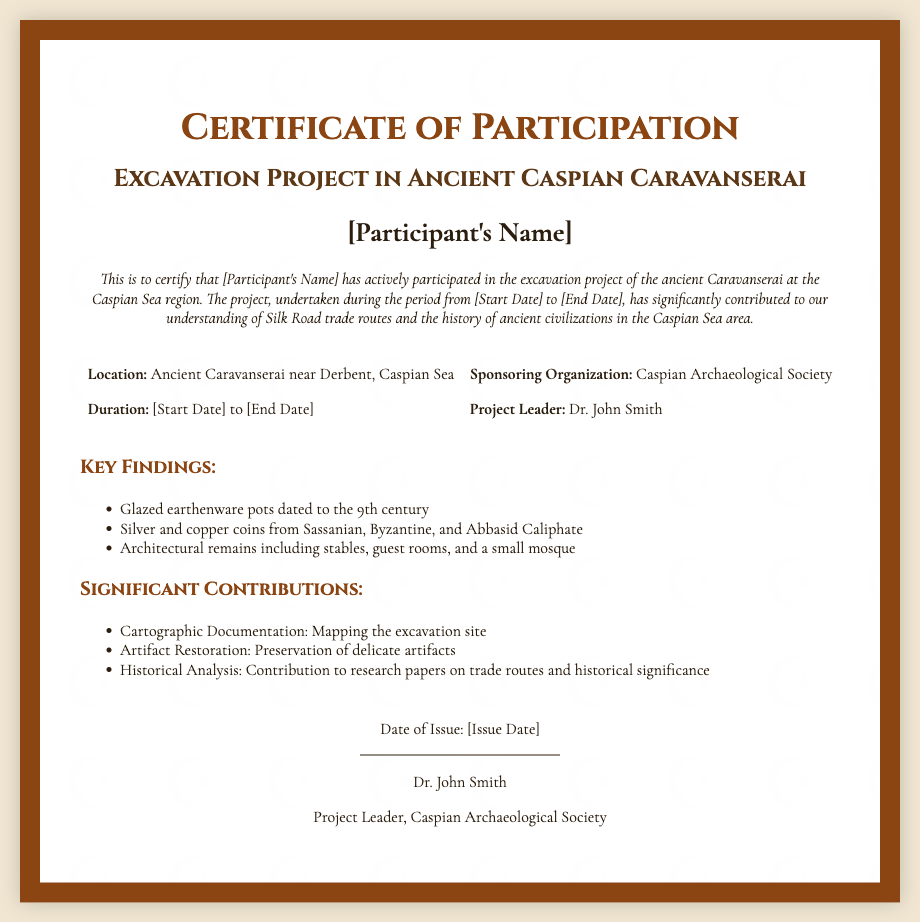What is the title of the project? The title of the project as stated in the certificate is "Excavation Project in Ancient Caspian Caravanserai".
Answer: Excavation Project in Ancient Caspian Caravanserai Who is the project leader? The document specifies the project leader's name as stated below the signature line.
Answer: Dr. John Smith What organization sponsored the project? The sponsoring organization is mentioned in the project details section.
Answer: Caspian Archaeological Society What is the location of the excavation? The document provides the location in the project details section.
Answer: Ancient Caravanserai near Derbent, Caspian Sea What are the dates of the project? The certificate includes a duration section where the start and end dates should be placed.
Answer: [Start Date] to [End Date] Name one key finding from the excavation. The document lists key findings that were discovered during the excavation.
Answer: Glazed earthenware pots dated to the 9th century What kind of artifact restoration was done? The contributions section mentions a specific type of work related to artifacts.
Answer: Preservation of delicate artifacts Who is being certified in this document? The certificate mentions the participant's name at the start of the description.
Answer: [Participant's Name] When was the certificate issued? The document states a date of issue in the signature section.
Answer: [Issue Date] 